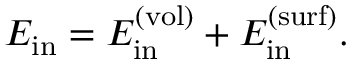<formula> <loc_0><loc_0><loc_500><loc_500>E _ { i n } = E _ { i n } ^ { ( v o l ) } + E _ { i n } ^ { ( s u r f ) } .</formula> 